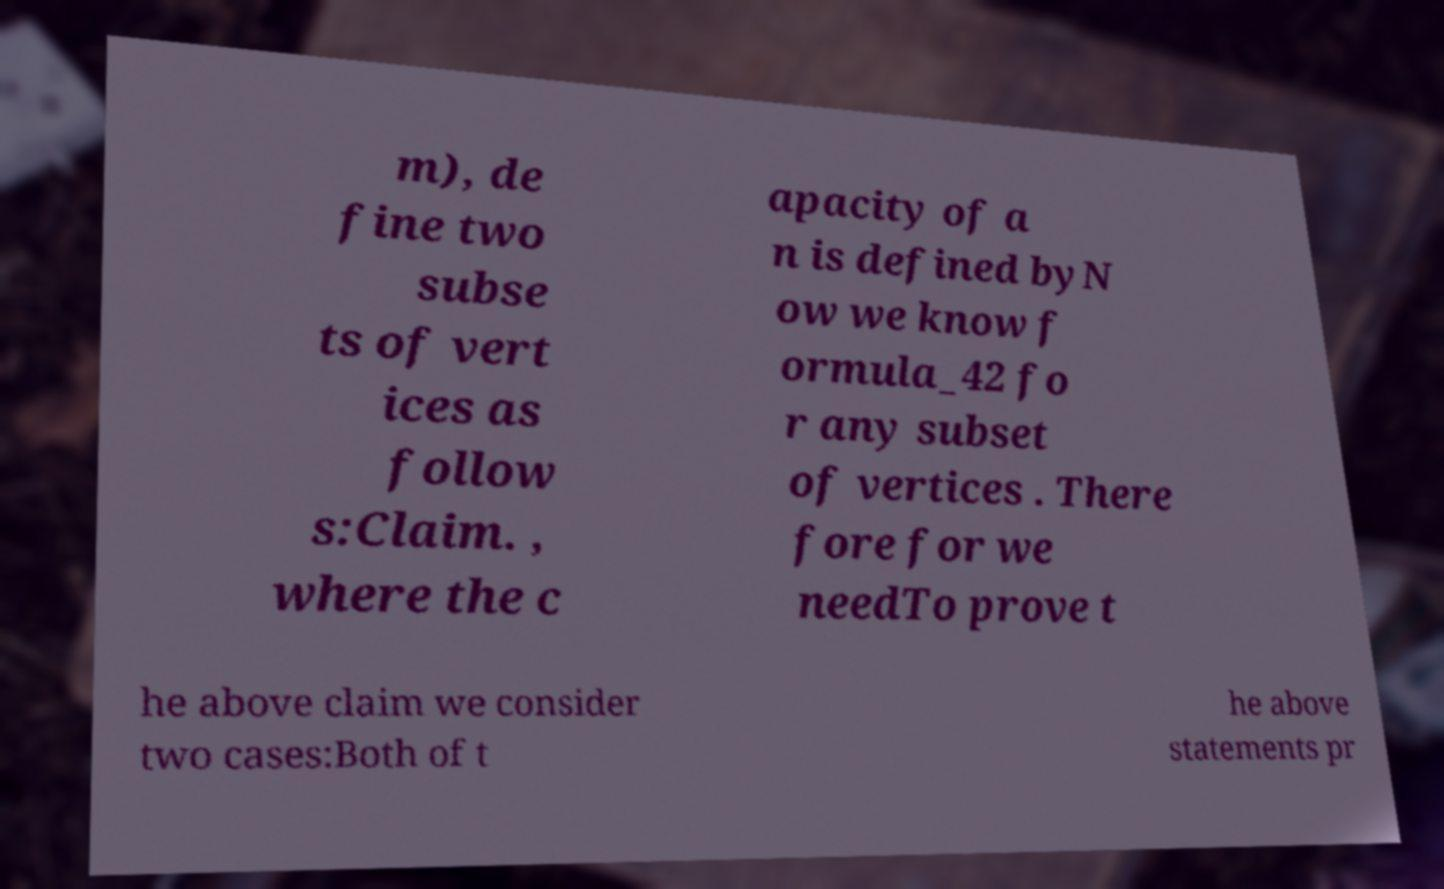There's text embedded in this image that I need extracted. Can you transcribe it verbatim? m), de fine two subse ts of vert ices as follow s:Claim. , where the c apacity of a n is defined byN ow we know f ormula_42 fo r any subset of vertices . There fore for we needTo prove t he above claim we consider two cases:Both of t he above statements pr 